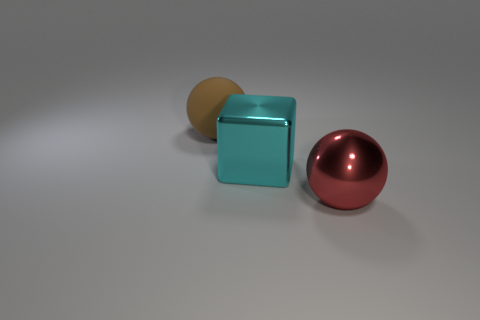What is the size of the ball right of the sphere behind the metallic thing behind the big metal ball? The ball to the right of the sphere, which is located behind the cube and further behind the larger metal sphere, appears to be reasonably smaller in size compared to the large metal sphere but slightly larger than the cube. 